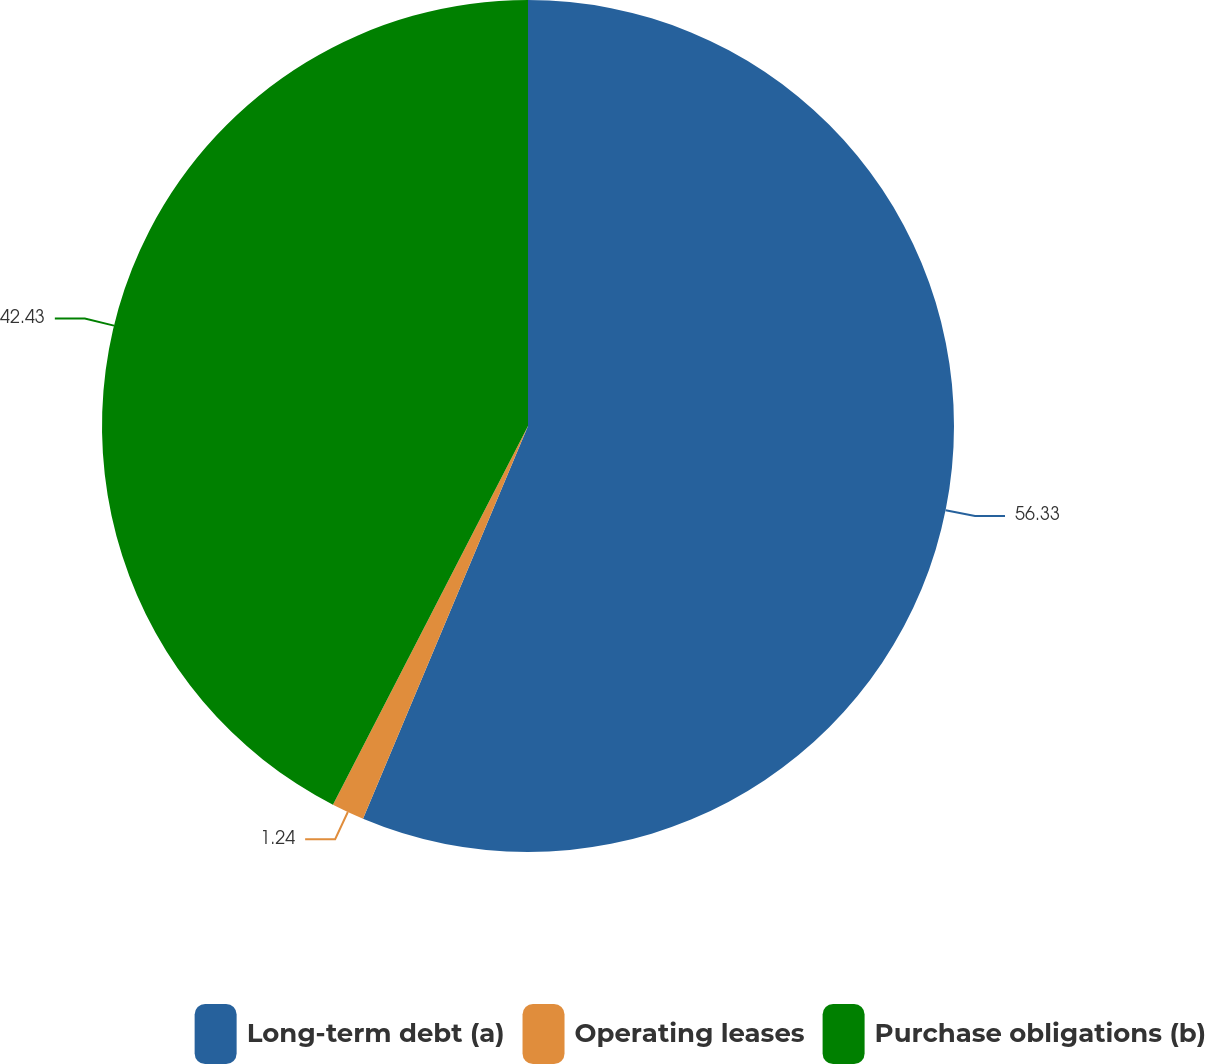<chart> <loc_0><loc_0><loc_500><loc_500><pie_chart><fcel>Long-term debt (a)<fcel>Operating leases<fcel>Purchase obligations (b)<nl><fcel>56.33%<fcel>1.24%<fcel>42.43%<nl></chart> 